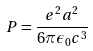<formula> <loc_0><loc_0><loc_500><loc_500>P = \frac { e ^ { 2 } a ^ { 2 } } { 6 \pi \epsilon _ { 0 } c ^ { 3 } }</formula> 